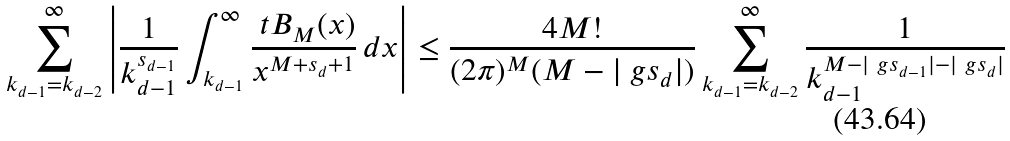<formula> <loc_0><loc_0><loc_500><loc_500>\sum _ { k _ { d - 1 } = k _ { d - 2 } } ^ { \infty } \left | \frac { 1 } { k _ { d - 1 } ^ { s _ { d - 1 } } } \int _ { k _ { d - 1 } } ^ { \infty } \frac { \ t B _ { M } ( x ) } { x ^ { M + s _ { d } + 1 } } \, d x \right | \leq \frac { 4 M ! } { ( 2 \pi ) ^ { M } ( M - | \ g s _ { d } | ) } \sum _ { k _ { d - 1 } = k _ { d - 2 } } ^ { \infty } \frac { 1 } { k _ { d - 1 } ^ { M - | \ g s _ { d - 1 } | - | \ g s _ { d } | } }</formula> 